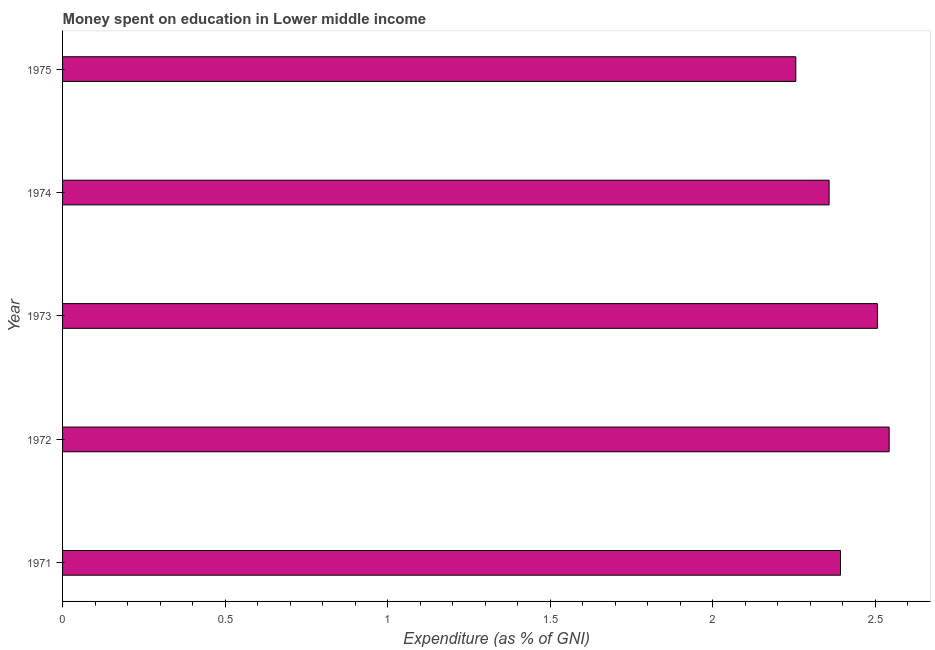What is the title of the graph?
Make the answer very short. Money spent on education in Lower middle income. What is the label or title of the X-axis?
Provide a succinct answer. Expenditure (as % of GNI). What is the expenditure on education in 1972?
Give a very brief answer. 2.54. Across all years, what is the maximum expenditure on education?
Offer a very short reply. 2.54. Across all years, what is the minimum expenditure on education?
Your answer should be compact. 2.26. In which year was the expenditure on education maximum?
Your response must be concise. 1972. In which year was the expenditure on education minimum?
Provide a short and direct response. 1975. What is the sum of the expenditure on education?
Give a very brief answer. 12.06. What is the difference between the expenditure on education in 1972 and 1973?
Keep it short and to the point. 0.04. What is the average expenditure on education per year?
Offer a very short reply. 2.41. What is the median expenditure on education?
Make the answer very short. 2.39. What is the ratio of the expenditure on education in 1971 to that in 1975?
Offer a very short reply. 1.06. Is the expenditure on education in 1971 less than that in 1973?
Keep it short and to the point. Yes. Is the difference between the expenditure on education in 1971 and 1974 greater than the difference between any two years?
Your answer should be very brief. No. What is the difference between the highest and the second highest expenditure on education?
Provide a succinct answer. 0.04. Is the sum of the expenditure on education in 1972 and 1975 greater than the maximum expenditure on education across all years?
Give a very brief answer. Yes. What is the difference between the highest and the lowest expenditure on education?
Your answer should be compact. 0.29. In how many years, is the expenditure on education greater than the average expenditure on education taken over all years?
Offer a very short reply. 2. How many bars are there?
Your answer should be compact. 5. What is the Expenditure (as % of GNI) of 1971?
Your answer should be compact. 2.39. What is the Expenditure (as % of GNI) of 1972?
Give a very brief answer. 2.54. What is the Expenditure (as % of GNI) in 1973?
Offer a very short reply. 2.51. What is the Expenditure (as % of GNI) in 1974?
Offer a very short reply. 2.36. What is the Expenditure (as % of GNI) in 1975?
Offer a terse response. 2.26. What is the difference between the Expenditure (as % of GNI) in 1971 and 1972?
Your answer should be compact. -0.15. What is the difference between the Expenditure (as % of GNI) in 1971 and 1973?
Keep it short and to the point. -0.11. What is the difference between the Expenditure (as % of GNI) in 1971 and 1974?
Your response must be concise. 0.04. What is the difference between the Expenditure (as % of GNI) in 1971 and 1975?
Offer a very short reply. 0.14. What is the difference between the Expenditure (as % of GNI) in 1972 and 1973?
Your answer should be compact. 0.04. What is the difference between the Expenditure (as % of GNI) in 1972 and 1974?
Your response must be concise. 0.18. What is the difference between the Expenditure (as % of GNI) in 1972 and 1975?
Provide a succinct answer. 0.29. What is the difference between the Expenditure (as % of GNI) in 1973 and 1974?
Keep it short and to the point. 0.15. What is the difference between the Expenditure (as % of GNI) in 1973 and 1975?
Keep it short and to the point. 0.25. What is the difference between the Expenditure (as % of GNI) in 1974 and 1975?
Your response must be concise. 0.1. What is the ratio of the Expenditure (as % of GNI) in 1971 to that in 1972?
Offer a very short reply. 0.94. What is the ratio of the Expenditure (as % of GNI) in 1971 to that in 1973?
Keep it short and to the point. 0.95. What is the ratio of the Expenditure (as % of GNI) in 1971 to that in 1975?
Offer a terse response. 1.06. What is the ratio of the Expenditure (as % of GNI) in 1972 to that in 1974?
Your answer should be compact. 1.08. What is the ratio of the Expenditure (as % of GNI) in 1972 to that in 1975?
Offer a terse response. 1.13. What is the ratio of the Expenditure (as % of GNI) in 1973 to that in 1974?
Offer a terse response. 1.06. What is the ratio of the Expenditure (as % of GNI) in 1973 to that in 1975?
Offer a terse response. 1.11. What is the ratio of the Expenditure (as % of GNI) in 1974 to that in 1975?
Make the answer very short. 1.04. 